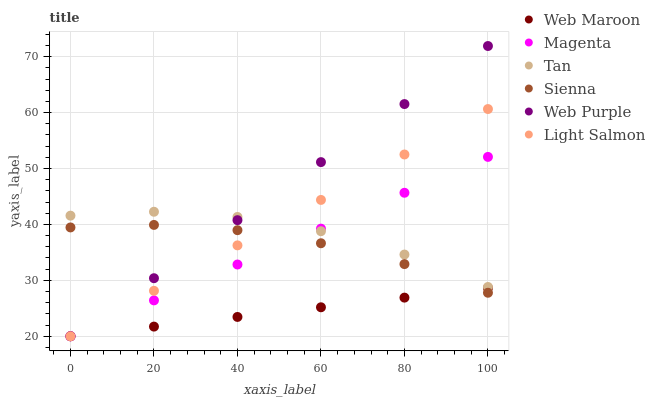Does Web Maroon have the minimum area under the curve?
Answer yes or no. Yes. Does Web Purple have the maximum area under the curve?
Answer yes or no. Yes. Does Sienna have the minimum area under the curve?
Answer yes or no. No. Does Sienna have the maximum area under the curve?
Answer yes or no. No. Is Web Maroon the smoothest?
Answer yes or no. Yes. Is Tan the roughest?
Answer yes or no. Yes. Is Sienna the smoothest?
Answer yes or no. No. Is Sienna the roughest?
Answer yes or no. No. Does Light Salmon have the lowest value?
Answer yes or no. Yes. Does Sienna have the lowest value?
Answer yes or no. No. Does Web Purple have the highest value?
Answer yes or no. Yes. Does Sienna have the highest value?
Answer yes or no. No. Is Web Maroon less than Tan?
Answer yes or no. Yes. Is Tan greater than Web Maroon?
Answer yes or no. Yes. Does Magenta intersect Tan?
Answer yes or no. Yes. Is Magenta less than Tan?
Answer yes or no. No. Is Magenta greater than Tan?
Answer yes or no. No. Does Web Maroon intersect Tan?
Answer yes or no. No. 